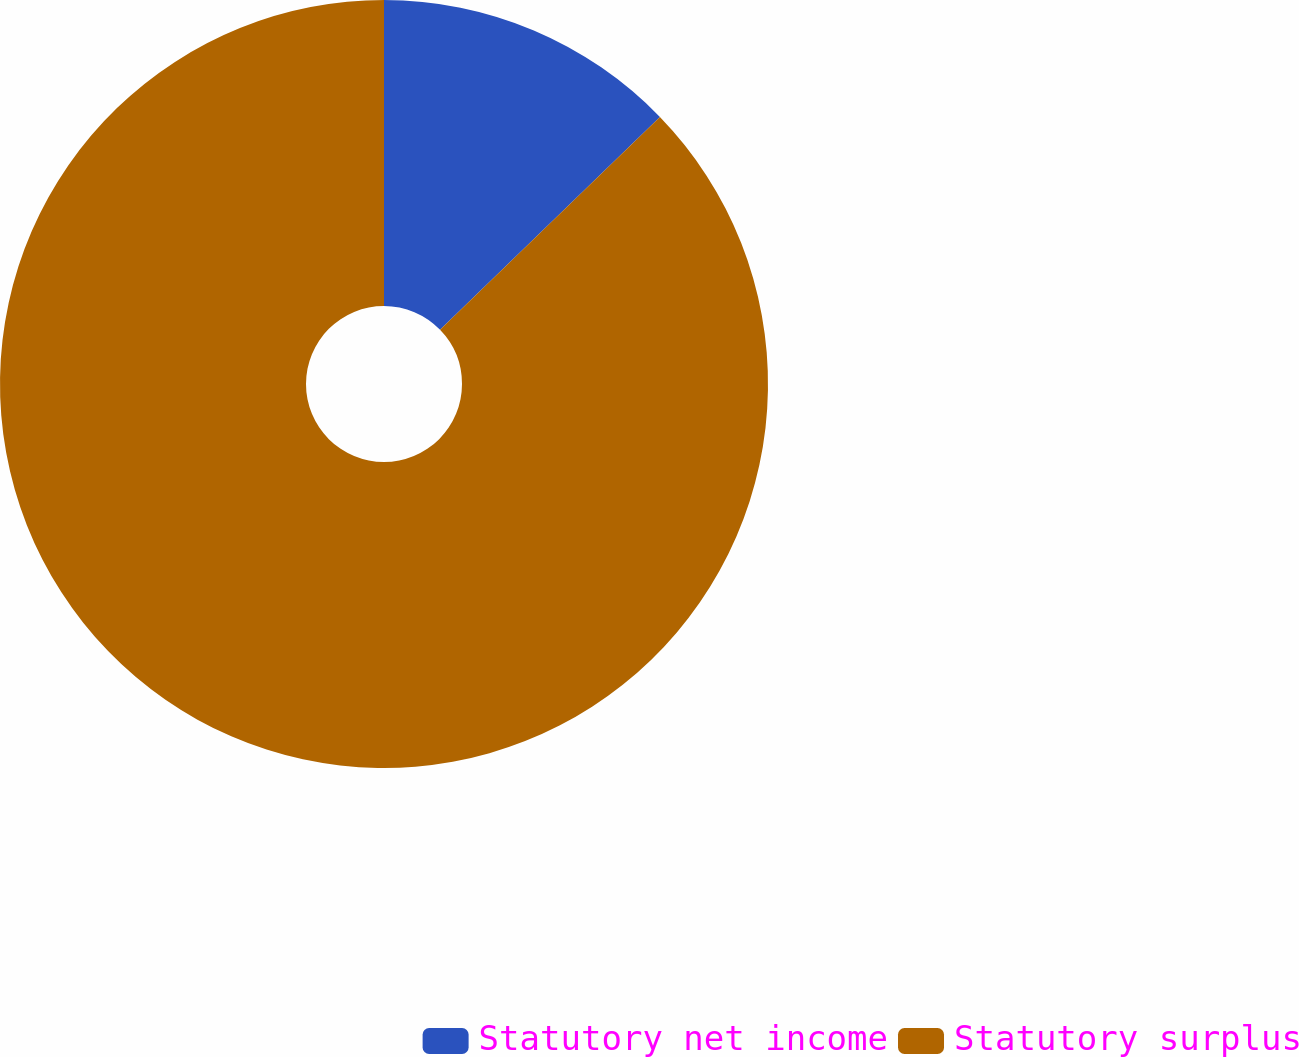Convert chart to OTSL. <chart><loc_0><loc_0><loc_500><loc_500><pie_chart><fcel>Statutory net income<fcel>Statutory surplus<nl><fcel>12.76%<fcel>87.24%<nl></chart> 